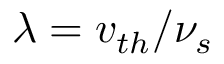Convert formula to latex. <formula><loc_0><loc_0><loc_500><loc_500>\lambda = v _ { t h } / \nu _ { s }</formula> 